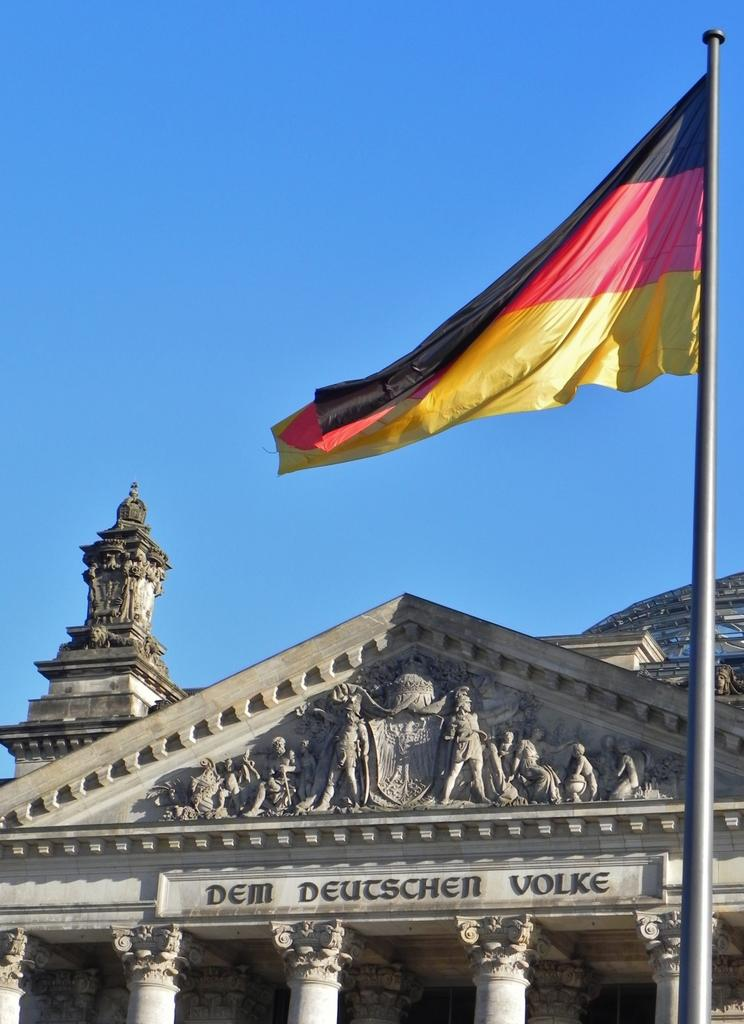What type of structure is present in the image? There is a building in the image. Are there any decorative elements on the building? Yes, there is a sculpture on the building. What other object can be seen in the image? There is a flag in the image. What is visible in the background of the image? The sky is visible in the image. Can you tell me how many straws are used to hold up the sculpture on the building? There is no mention of straws being used to hold up the sculpture on the building in the image. 